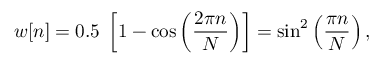Convert formula to latex. <formula><loc_0><loc_0><loc_500><loc_500>w [ n ] = 0 . 5 \, \left [ 1 - \cos \left ( { \frac { 2 \pi n } { N } } \right ) \right ] = \sin ^ { 2 } \left ( { \frac { \pi n } { N } } \right ) ,</formula> 